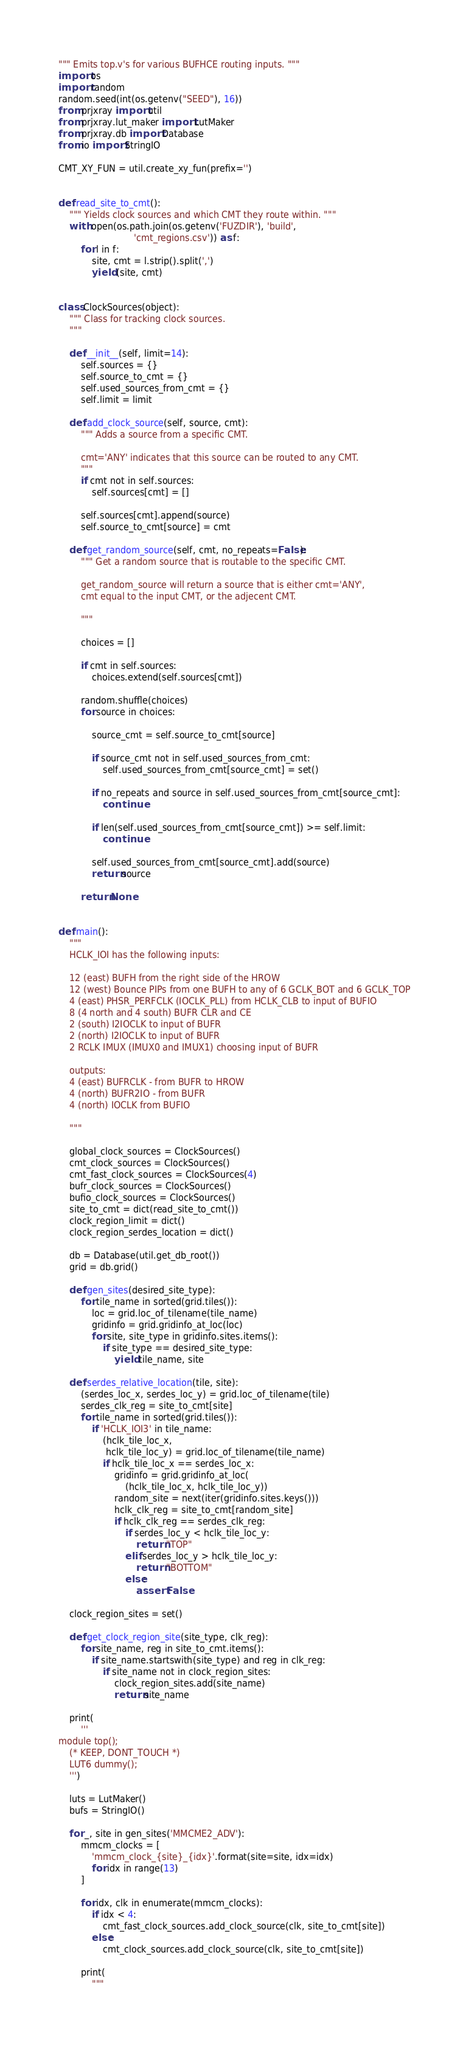Convert code to text. <code><loc_0><loc_0><loc_500><loc_500><_Python_>""" Emits top.v's for various BUFHCE routing inputs. """
import os
import random
random.seed(int(os.getenv("SEED"), 16))
from prjxray import util
from prjxray.lut_maker import LutMaker
from prjxray.db import Database
from io import StringIO

CMT_XY_FUN = util.create_xy_fun(prefix='')


def read_site_to_cmt():
    """ Yields clock sources and which CMT they route within. """
    with open(os.path.join(os.getenv('FUZDIR'), 'build',
                           'cmt_regions.csv')) as f:
        for l in f:
            site, cmt = l.strip().split(',')
            yield (site, cmt)


class ClockSources(object):
    """ Class for tracking clock sources.
    """

    def __init__(self, limit=14):
        self.sources = {}
        self.source_to_cmt = {}
        self.used_sources_from_cmt = {}
        self.limit = limit

    def add_clock_source(self, source, cmt):
        """ Adds a source from a specific CMT.

        cmt='ANY' indicates that this source can be routed to any CMT.
        """
        if cmt not in self.sources:
            self.sources[cmt] = []

        self.sources[cmt].append(source)
        self.source_to_cmt[source] = cmt

    def get_random_source(self, cmt, no_repeats=False):
        """ Get a random source that is routable to the specific CMT.

        get_random_source will return a source that is either cmt='ANY',
        cmt equal to the input CMT, or the adjecent CMT.

        """

        choices = []

        if cmt in self.sources:
            choices.extend(self.sources[cmt])

        random.shuffle(choices)
        for source in choices:

            source_cmt = self.source_to_cmt[source]

            if source_cmt not in self.used_sources_from_cmt:
                self.used_sources_from_cmt[source_cmt] = set()

            if no_repeats and source in self.used_sources_from_cmt[source_cmt]:
                continue

            if len(self.used_sources_from_cmt[source_cmt]) >= self.limit:
                continue

            self.used_sources_from_cmt[source_cmt].add(source)
            return source

        return None


def main():
    """
    HCLK_IOI has the following inputs:

    12 (east) BUFH from the right side of the HROW
    12 (west) Bounce PIPs from one BUFH to any of 6 GCLK_BOT and 6 GCLK_TOP
    4 (east) PHSR_PERFCLK (IOCLK_PLL) from HCLK_CLB to input of BUFIO
    8 (4 north and 4 south) BUFR CLR and CE
    2 (south) I2IOCLK to input of BUFR
    2 (north) I2IOCLK to input of BUFR
    2 RCLK IMUX (IMUX0 and IMUX1) choosing input of BUFR

    outputs:
    4 (east) BUFRCLK - from BUFR to HROW
    4 (north) BUFR2IO - from BUFR
    4 (north) IOCLK from BUFIO

    """

    global_clock_sources = ClockSources()
    cmt_clock_sources = ClockSources()
    cmt_fast_clock_sources = ClockSources(4)
    bufr_clock_sources = ClockSources()
    bufio_clock_sources = ClockSources()
    site_to_cmt = dict(read_site_to_cmt())
    clock_region_limit = dict()
    clock_region_serdes_location = dict()

    db = Database(util.get_db_root())
    grid = db.grid()

    def gen_sites(desired_site_type):
        for tile_name in sorted(grid.tiles()):
            loc = grid.loc_of_tilename(tile_name)
            gridinfo = grid.gridinfo_at_loc(loc)
            for site, site_type in gridinfo.sites.items():
                if site_type == desired_site_type:
                    yield tile_name, site

    def serdes_relative_location(tile, site):
        (serdes_loc_x, serdes_loc_y) = grid.loc_of_tilename(tile)
        serdes_clk_reg = site_to_cmt[site]
        for tile_name in sorted(grid.tiles()):
            if 'HCLK_IOI3' in tile_name:
                (hclk_tile_loc_x,
                 hclk_tile_loc_y) = grid.loc_of_tilename(tile_name)
                if hclk_tile_loc_x == serdes_loc_x:
                    gridinfo = grid.gridinfo_at_loc(
                        (hclk_tile_loc_x, hclk_tile_loc_y))
                    random_site = next(iter(gridinfo.sites.keys()))
                    hclk_clk_reg = site_to_cmt[random_site]
                    if hclk_clk_reg == serdes_clk_reg:
                        if serdes_loc_y < hclk_tile_loc_y:
                            return "TOP"
                        elif serdes_loc_y > hclk_tile_loc_y:
                            return "BOTTOM"
                        else:
                            assert False

    clock_region_sites = set()

    def get_clock_region_site(site_type, clk_reg):
        for site_name, reg in site_to_cmt.items():
            if site_name.startswith(site_type) and reg in clk_reg:
                if site_name not in clock_region_sites:
                    clock_region_sites.add(site_name)
                    return site_name

    print(
        '''
module top();
    (* KEEP, DONT_TOUCH *)
    LUT6 dummy();
    ''')

    luts = LutMaker()
    bufs = StringIO()

    for _, site in gen_sites('MMCME2_ADV'):
        mmcm_clocks = [
            'mmcm_clock_{site}_{idx}'.format(site=site, idx=idx)
            for idx in range(13)
        ]

        for idx, clk in enumerate(mmcm_clocks):
            if idx < 4:
                cmt_fast_clock_sources.add_clock_source(clk, site_to_cmt[site])
            else:
                cmt_clock_sources.add_clock_source(clk, site_to_cmt[site])

        print(
            """</code> 